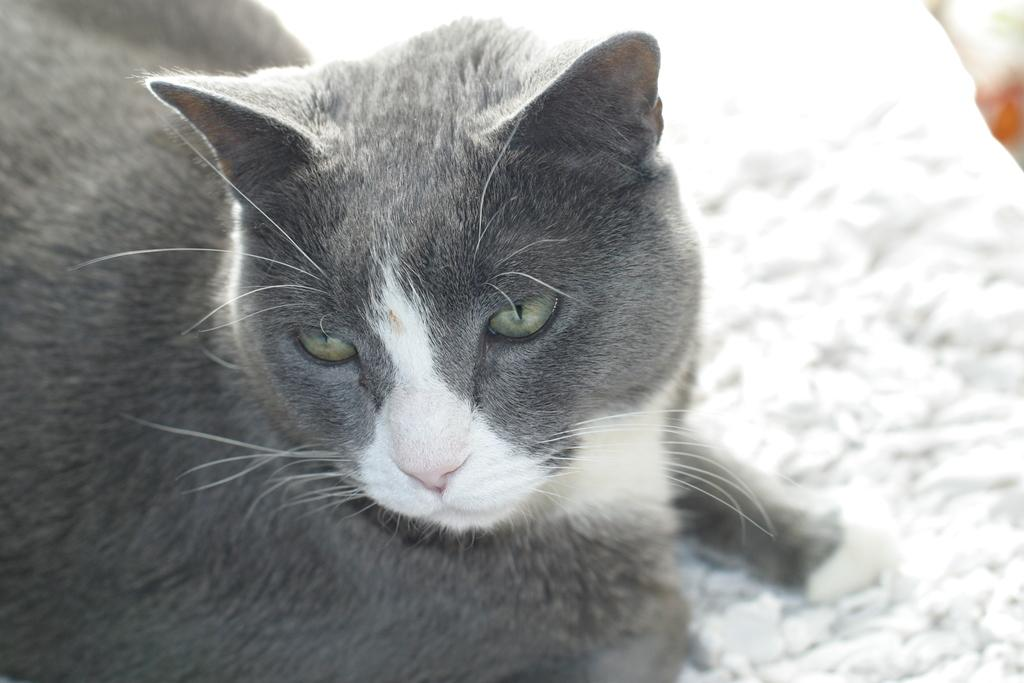What type of animal is in the image? There is a cat in the image. Can you describe the background of the image? The background of the image is blurred. What type of pencil is the cat using to write in the image? There is no pencil present in the image, and the cat is not writing. 